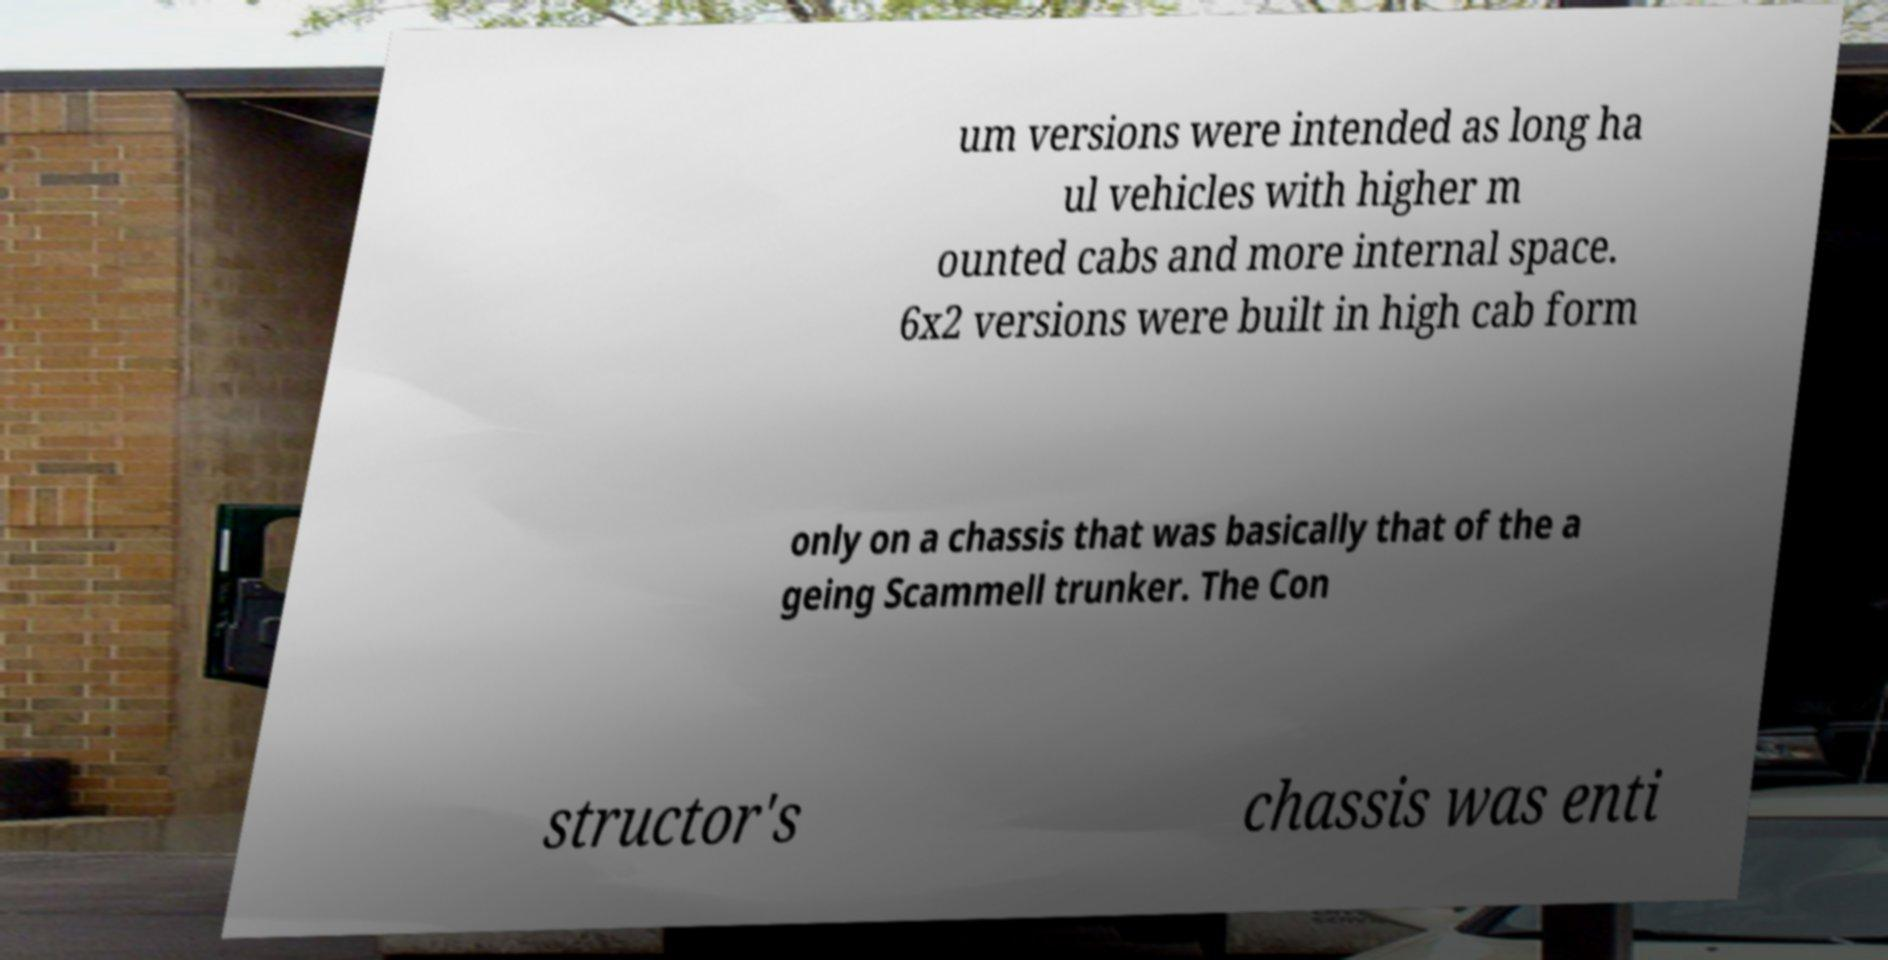Could you extract and type out the text from this image? um versions were intended as long ha ul vehicles with higher m ounted cabs and more internal space. 6x2 versions were built in high cab form only on a chassis that was basically that of the a geing Scammell trunker. The Con structor's chassis was enti 